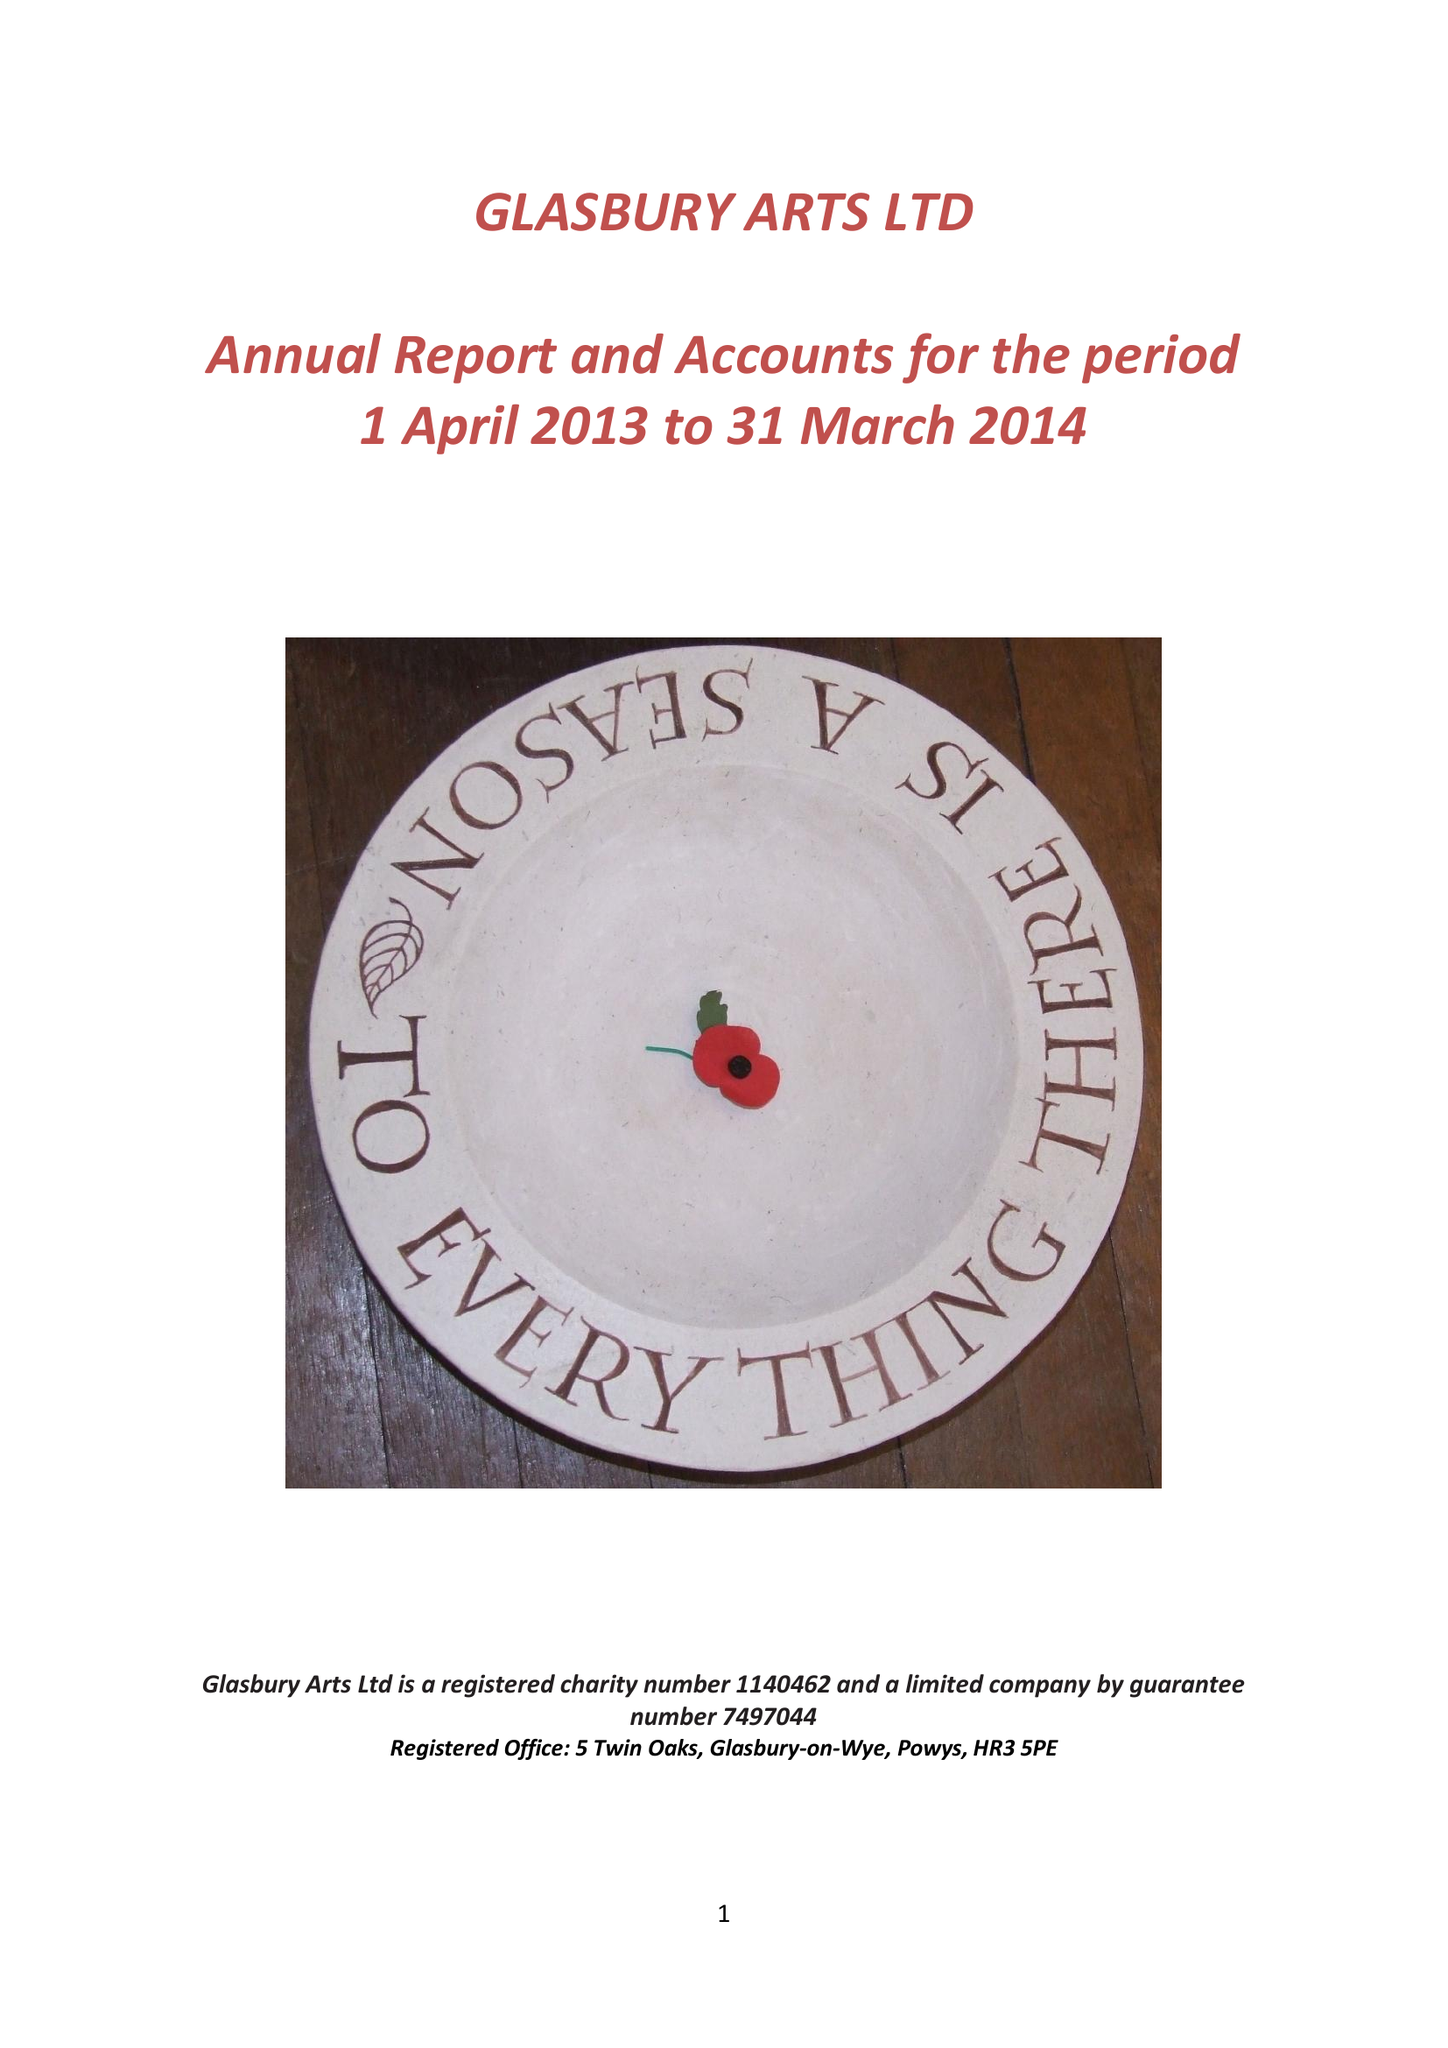What is the value for the charity_number?
Answer the question using a single word or phrase. 1140462 